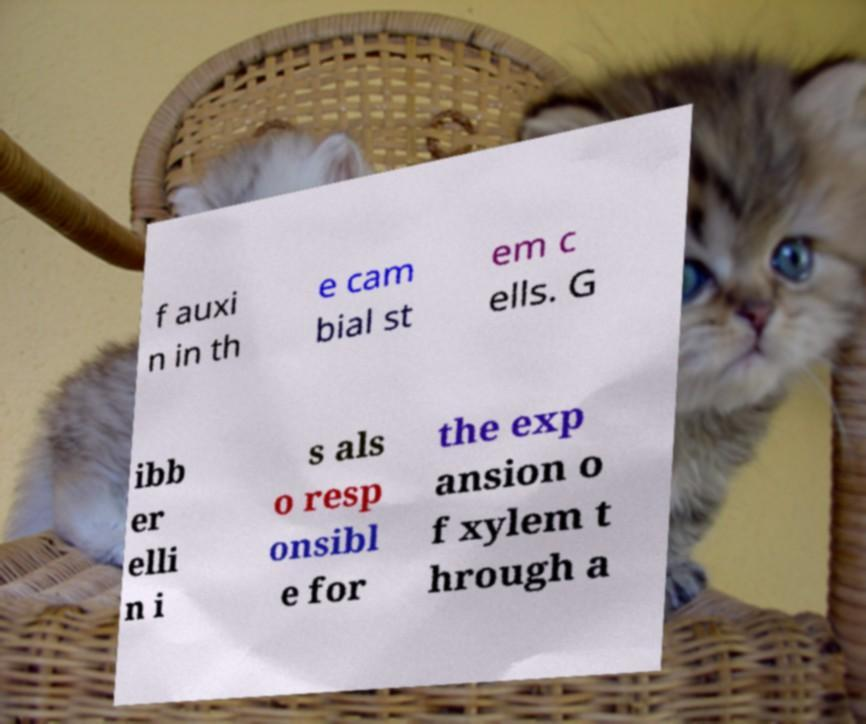Can you accurately transcribe the text from the provided image for me? f auxi n in th e cam bial st em c ells. G ibb er elli n i s als o resp onsibl e for the exp ansion o f xylem t hrough a 